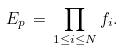<formula> <loc_0><loc_0><loc_500><loc_500>E _ { p } \, = \, \prod _ { 1 \leq i \leq N } f _ { i } .</formula> 